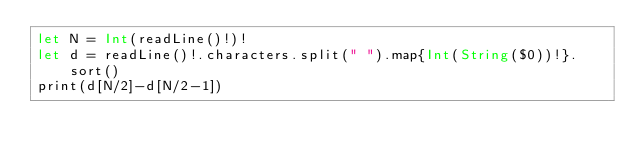Convert code to text. <code><loc_0><loc_0><loc_500><loc_500><_Swift_>let N = Int(readLine()!)!
let d = readLine()!.characters.split(" ").map{Int(String($0))!}.sort()
print(d[N/2]-d[N/2-1])</code> 